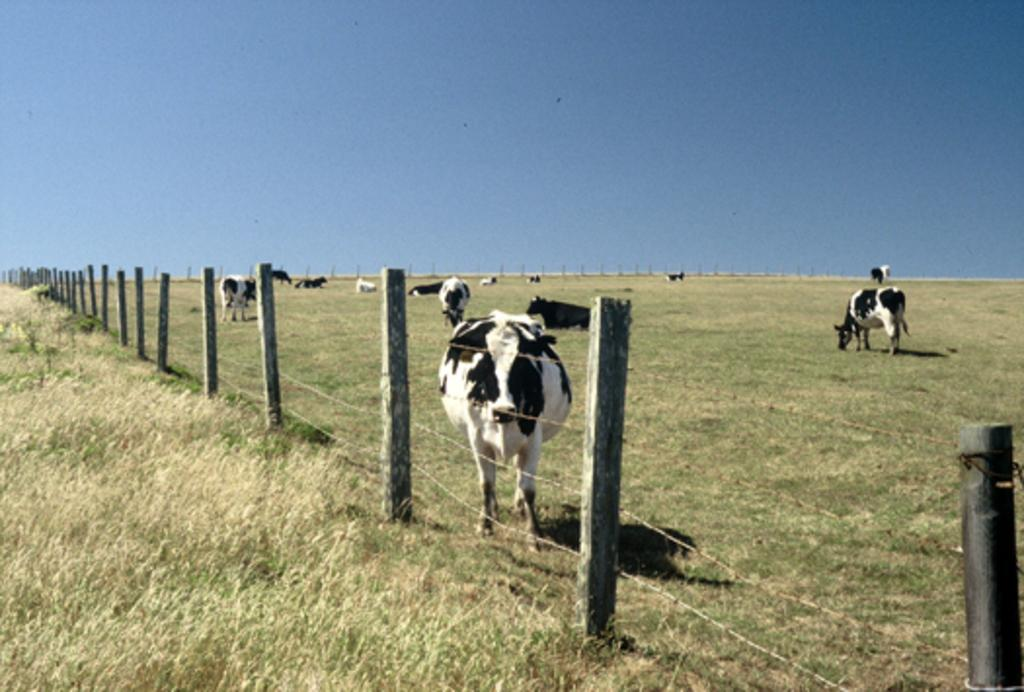What type of living organisms can be seen in the image? There are animals in the image. What is separating the animals from the rest of the image? There is a fence in the image. What type of vegetation is present at the bottom of the image? Grass is present at the bottom of the image. What can be seen in the background of the image? The sky is visible in the background of the image. What type of music can be heard playing in the background of the image? There is no music present in the image, as it is a still photograph. Can you see any ice in the image? There is no ice visible in the image. 